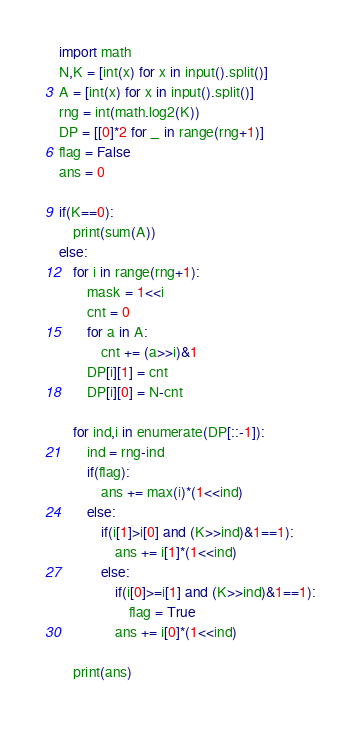<code> <loc_0><loc_0><loc_500><loc_500><_Python_>import math
N,K = [int(x) for x in input().split()]
A = [int(x) for x in input().split()]
rng = int(math.log2(K))
DP = [[0]*2 for _ in range(rng+1)]
flag = False
ans = 0

if(K==0):
    print(sum(A))
else:
    for i in range(rng+1):
        mask = 1<<i
        cnt = 0
        for a in A:
            cnt += (a>>i)&1
        DP[i][1] = cnt
        DP[i][0] = N-cnt

    for ind,i in enumerate(DP[::-1]):
        ind = rng-ind
        if(flag):
            ans += max(i)*(1<<ind)
        else:
            if(i[1]>i[0] and (K>>ind)&1==1):
                ans += i[1]*(1<<ind)
            else:
                if(i[0]>=i[1] and (K>>ind)&1==1):
                    flag = True
                ans += i[0]*(1<<ind)

    print(ans)
</code> 